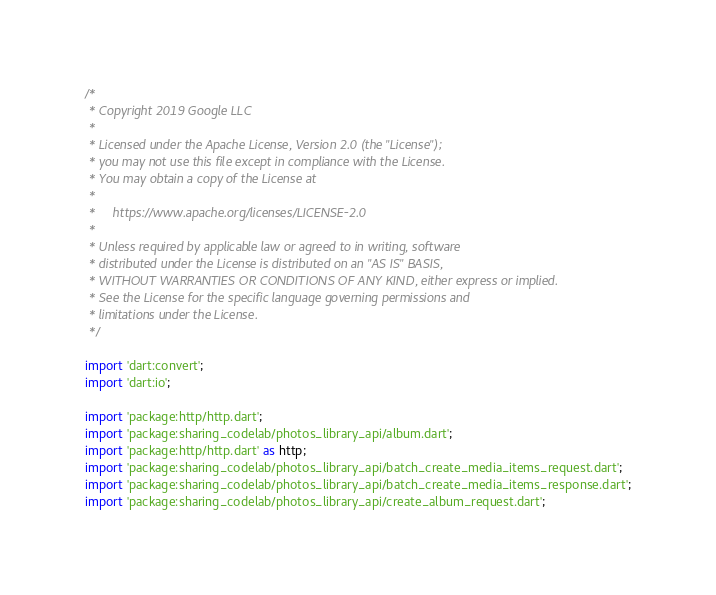Convert code to text. <code><loc_0><loc_0><loc_500><loc_500><_Dart_>/*
 * Copyright 2019 Google LLC
 *
 * Licensed under the Apache License, Version 2.0 (the "License");
 * you may not use this file except in compliance with the License.
 * You may obtain a copy of the License at
 *
 *     https://www.apache.org/licenses/LICENSE-2.0
 *
 * Unless required by applicable law or agreed to in writing, software
 * distributed under the License is distributed on an "AS IS" BASIS,
 * WITHOUT WARRANTIES OR CONDITIONS OF ANY KIND, either express or implied.
 * See the License for the specific language governing permissions and
 * limitations under the License.
 */

import 'dart:convert';
import 'dart:io';

import 'package:http/http.dart';
import 'package:sharing_codelab/photos_library_api/album.dart';
import 'package:http/http.dart' as http;
import 'package:sharing_codelab/photos_library_api/batch_create_media_items_request.dart';
import 'package:sharing_codelab/photos_library_api/batch_create_media_items_response.dart';
import 'package:sharing_codelab/photos_library_api/create_album_request.dart';</code> 